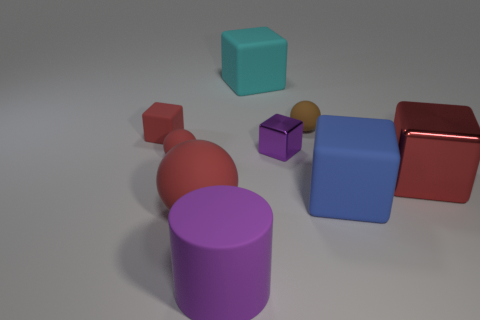Subtract 2 cubes. How many cubes are left? 3 Subtract all cyan cubes. How many cubes are left? 4 Subtract all large cyan blocks. How many blocks are left? 4 Subtract all brown blocks. Subtract all cyan cylinders. How many blocks are left? 5 Add 1 big metallic objects. How many objects exist? 10 Subtract all balls. How many objects are left? 6 Add 8 small metallic things. How many small metallic things exist? 9 Subtract 0 blue balls. How many objects are left? 9 Subtract all matte cylinders. Subtract all small red things. How many objects are left? 6 Add 5 cyan rubber blocks. How many cyan rubber blocks are left? 6 